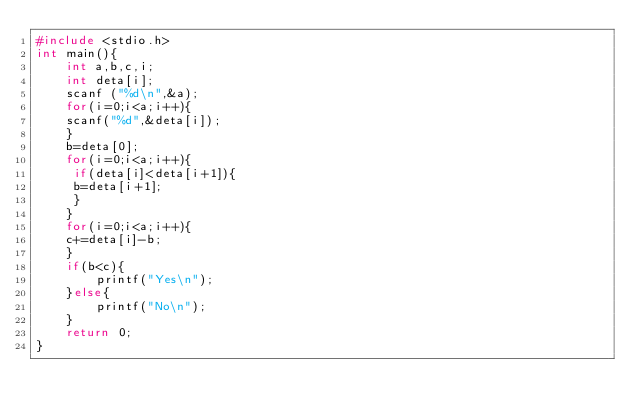<code> <loc_0><loc_0><loc_500><loc_500><_C_>#include <stdio.h>
int main(){
    int a,b,c,i;
    int deta[i];
    scanf ("%d\n",&a);
    for(i=0;i<a;i++){
    scanf("%d",&deta[i]);
    }
    b=deta[0];
    for(i=0;i<a;i++){
     if(deta[i]<deta[i+1]){
     b=deta[i+1];
     }
    }
    for(i=0;i<a;i++){
    c+=deta[i]-b;
    }
    if(b<c){
        printf("Yes\n");
    }else{
        printf("No\n");
    }
    return 0;
}</code> 